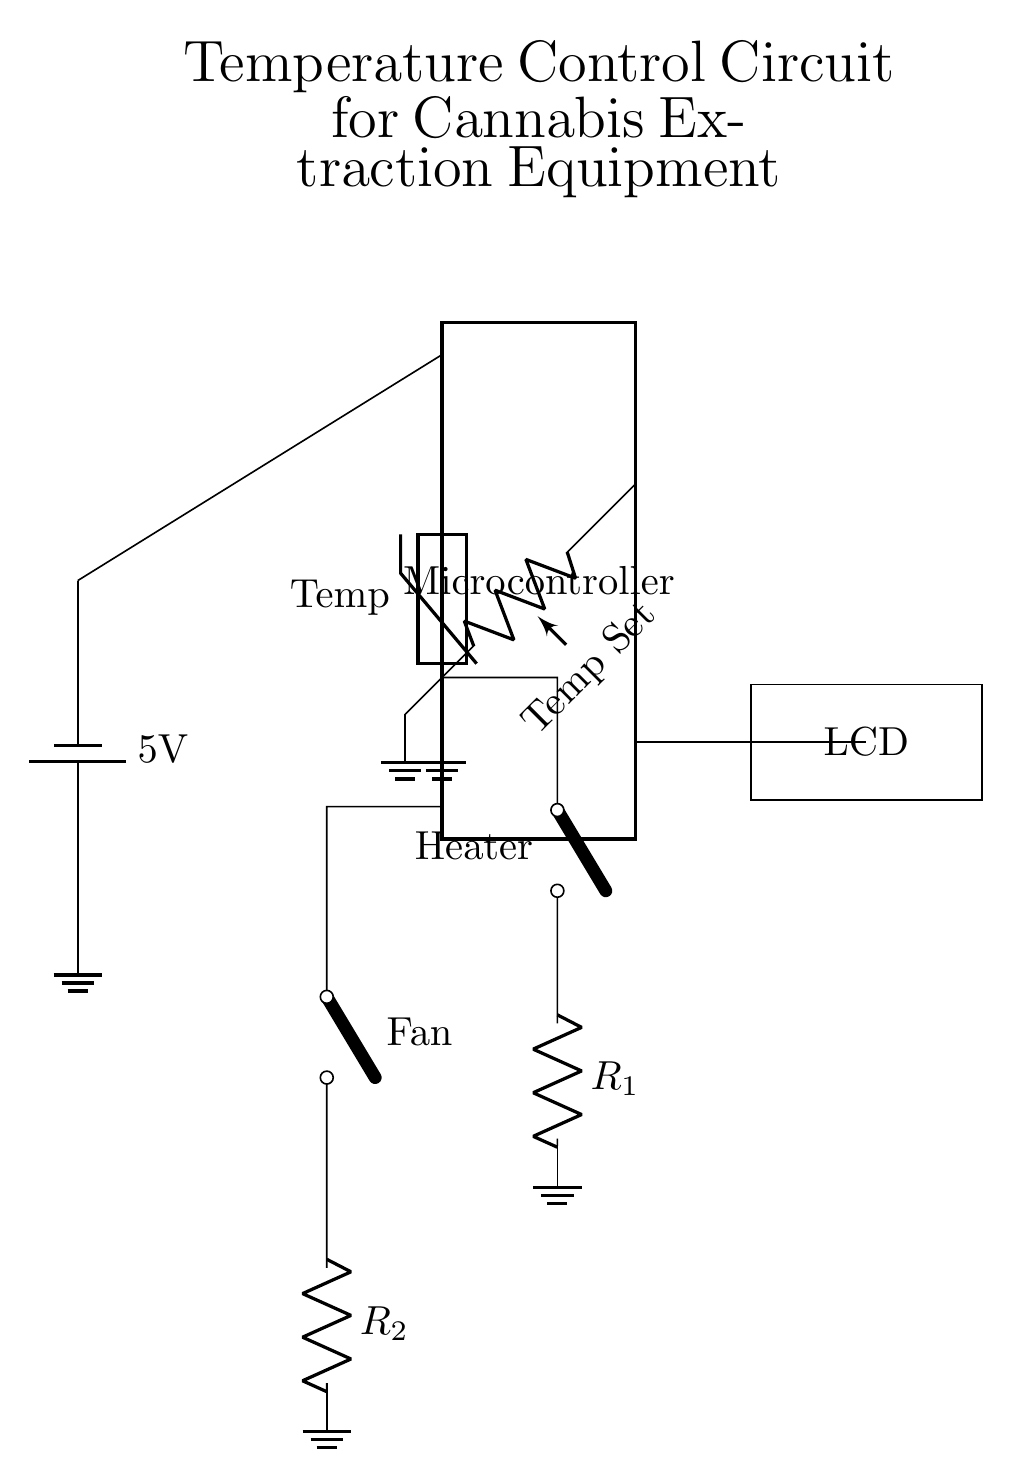What type of temperature sensor is used? The circuit diagram specifies a thermistor as the temperature sensor, used for measuring temperature by changing its resistance.
Answer: Thermistor What is the function of the potentiometer in the circuit? The potentiometer is labeled as "Temp Set," indicating its role in allowing the user to set a desired temperature threshold for the system to maintain.
Answer: Temperature setting What voltage is supplied to the microcontroller? The circuit shows a battery supplying 5 volts to the microcontroller, demonstrating the operating voltage for the device.
Answer: Five volts How many pins does the microcontroller have? The microcontroller in the diagram is represented with 16 pins, which indicates the number of connection points available for inputs, outputs, and power.
Answer: Sixteen pins What components are controlled by the microcontroller? The diagram highlights that the microcontroller controls a heater and a cooling fan through switches, which indicates it manages heating and cooling in the extraction process.
Answer: Heater and fan Why is there a switch labeled "Heater"? The switch marked "Heater" is used for controlling the power supply to the heating element, allowing the microcontroller to turn the heater on or off based on the temperature readings.
Answer: Power control What is displayed on the LCD? The circuit does not specify what is displayed on the LCD, but it is generally used for providing feedback, such as current temperature, set temperature, and system status.
Answer: System feedback 